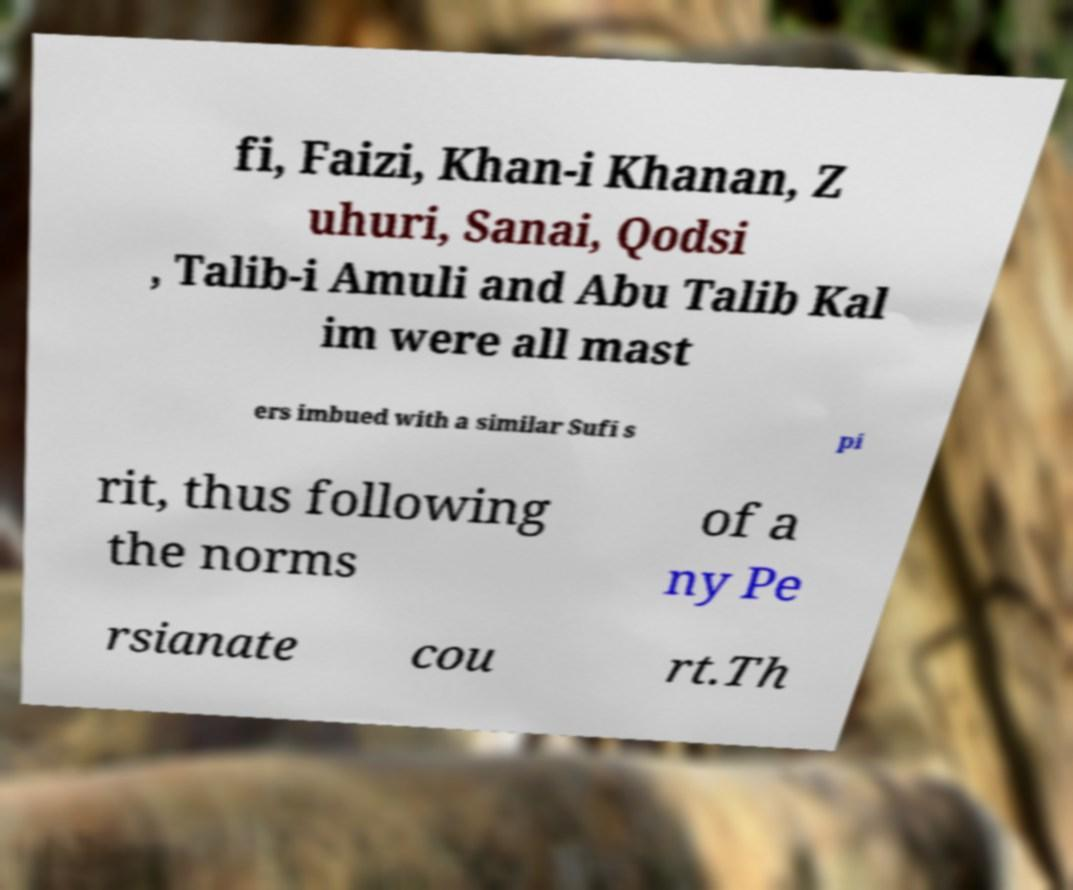There's text embedded in this image that I need extracted. Can you transcribe it verbatim? fi, Faizi, Khan-i Khanan, Z uhuri, Sanai, Qodsi , Talib-i Amuli and Abu Talib Kal im were all mast ers imbued with a similar Sufi s pi rit, thus following the norms of a ny Pe rsianate cou rt.Th 